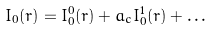<formula> <loc_0><loc_0><loc_500><loc_500>I _ { 0 } ( { r } ) = I _ { 0 } ^ { 0 } ( { r } ) + a _ { c } I _ { 0 } ^ { 1 } ( { r } ) + \dots</formula> 